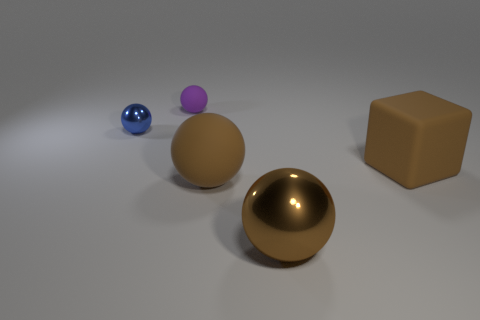Subtract all yellow balls. Subtract all yellow cylinders. How many balls are left? 4 Add 3 big green metallic things. How many objects exist? 8 Subtract all spheres. How many objects are left? 1 Add 2 metal balls. How many metal balls are left? 4 Add 2 small purple metallic cylinders. How many small purple metallic cylinders exist? 2 Subtract 0 gray blocks. How many objects are left? 5 Subtract all tiny blocks. Subtract all big brown objects. How many objects are left? 2 